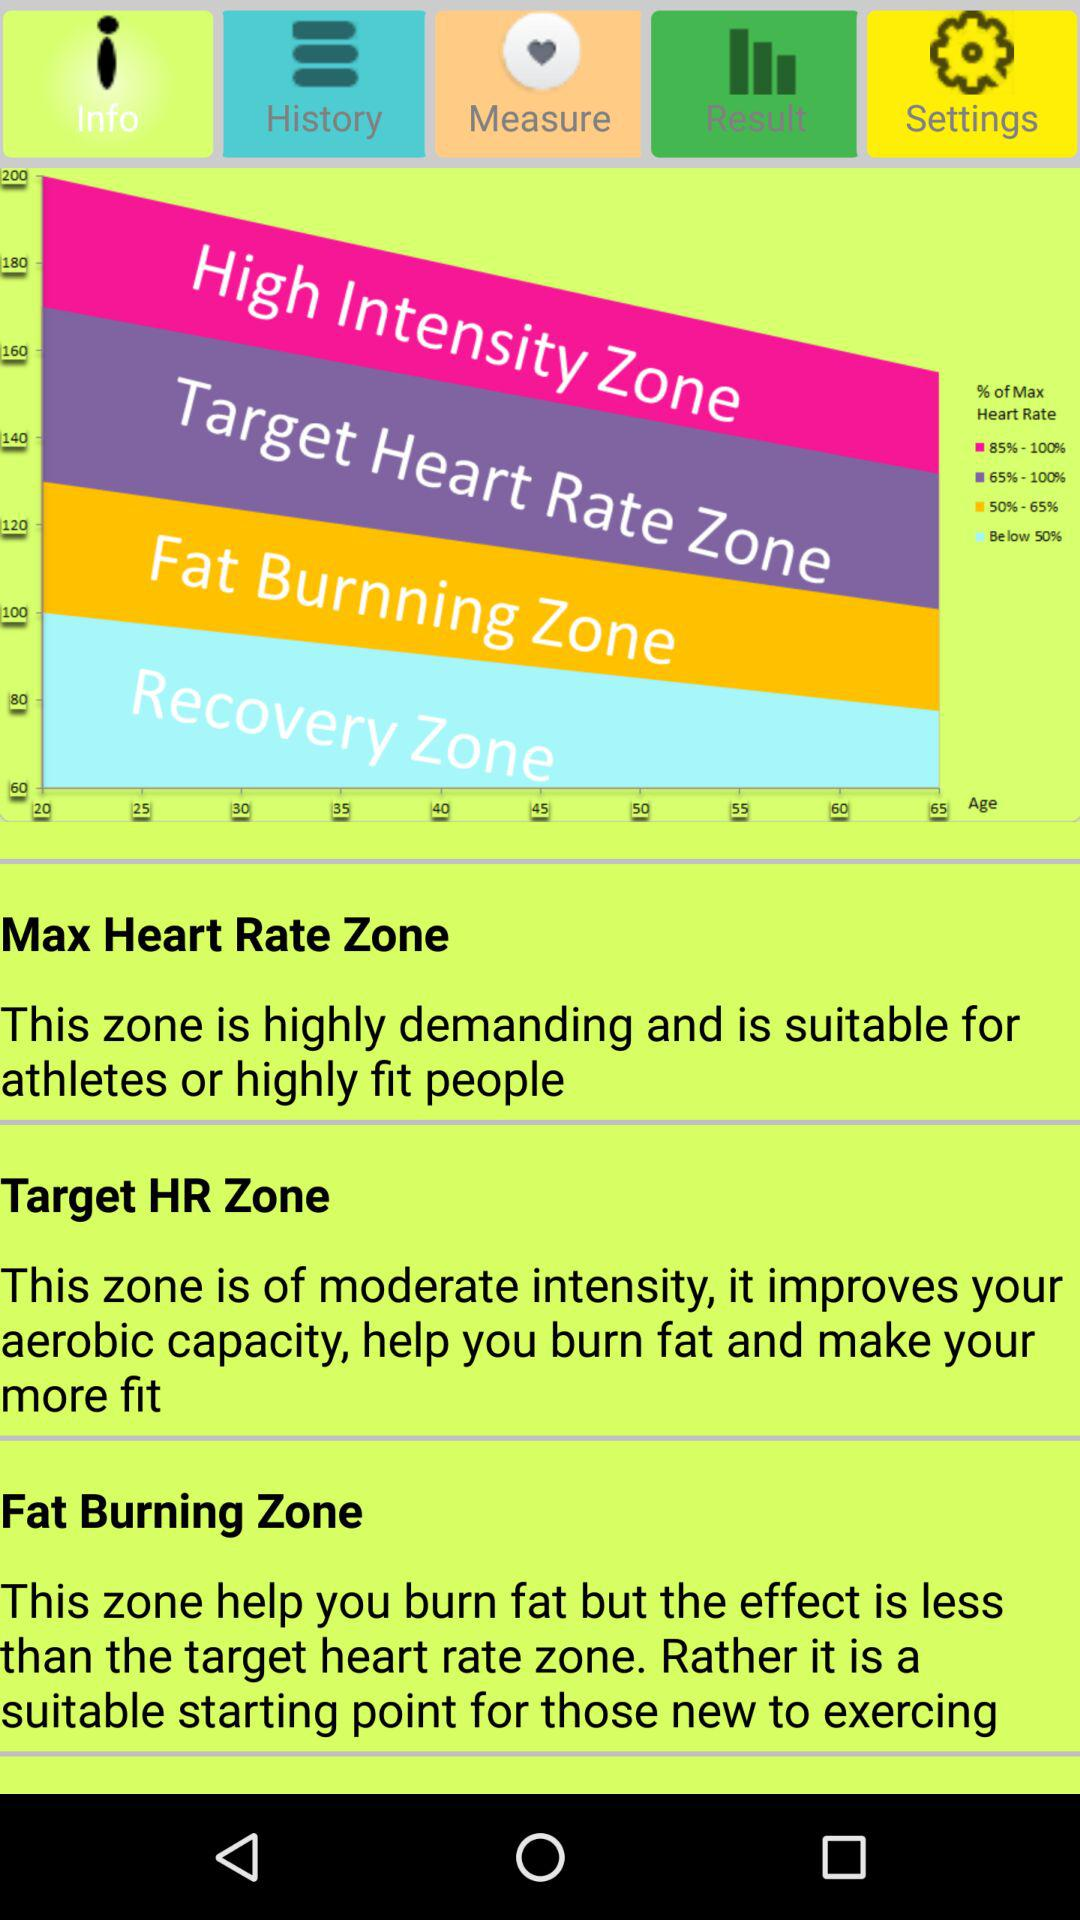What are the names of the zones? The names of the zones are "High Intensity Zone", "Target Heart Rate Zone", "Fat Burnning Zone", "Recovery Zone" and "Max Heart Rate Zone". 